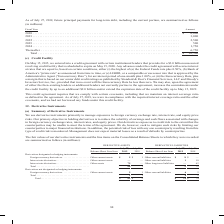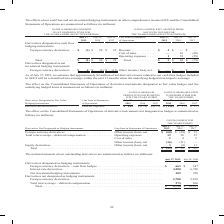According to Cisco Systems's financial document, How does the company mitigate credit risk associated with derivatives? Based on the financial document, the answer is by limiting our counterparties to major financial institutions. In addition, the potential risk of loss with any one counterparty resulting from this type of credit risk is monitored. Also, What were the cash flow hedges value in 2019? According to the financial document, 663 (in millions). The relevant text states: "� � � � � � � � � � � � � � � � � � � � � � � � $ 663 $ 147 Interest rate derivatives � � � � � � � � � � � � � � � � � � � � � � � � � � � � � � � � � �..." Also, Which years does the table provide information for the company's outstanding derivatives? The document shows two values: 2019 and 2018. From the document: "Balance Sheet Line Item July 27, 2019 July 28, 2018 Balance Sheet Line Item July 27, 2019 July 28, 2018 Derivatives designated as hedging Balance Shee..." Also, can you calculate: What was the change in the Net investment hedging instruments between 2018 and 2019? Based on the calculation: 309-250, the result is 59 (in millions). This is based on the information: "� � � � � � � � � � � � � � � � � � � � � � � � � 309 250 Derivatives not designated as hedging instruments: Foreign currency derivatives � � � � � � � � � � � � � � � � � � � � � � � � � � � � � � � ..." The key data points involved are: 250, 309. Also, How many years did foreign currency derivatives exceed $2,000 million? Counting the relevant items in the document: 2019, 2018, I find 2 instances. The key data points involved are: 2018, 2019. Also, can you calculate: What was the percentage change in the total amount of outstanding derivatives between 2018 and 2019? To answer this question, I need to perform calculations using the financial data. The calculation is: (8,754-10,011)/10,011, which equals -12.56 (percentage). This is based on the information: "� � � � � � � � � � � � � � � � � � � � $ 8,754 $ 10,011 � � � � � � � � � � � � � � � � � � � � � � � � $ 8,754 $ 10,011..." The key data points involved are: 10,011, 8,754. 